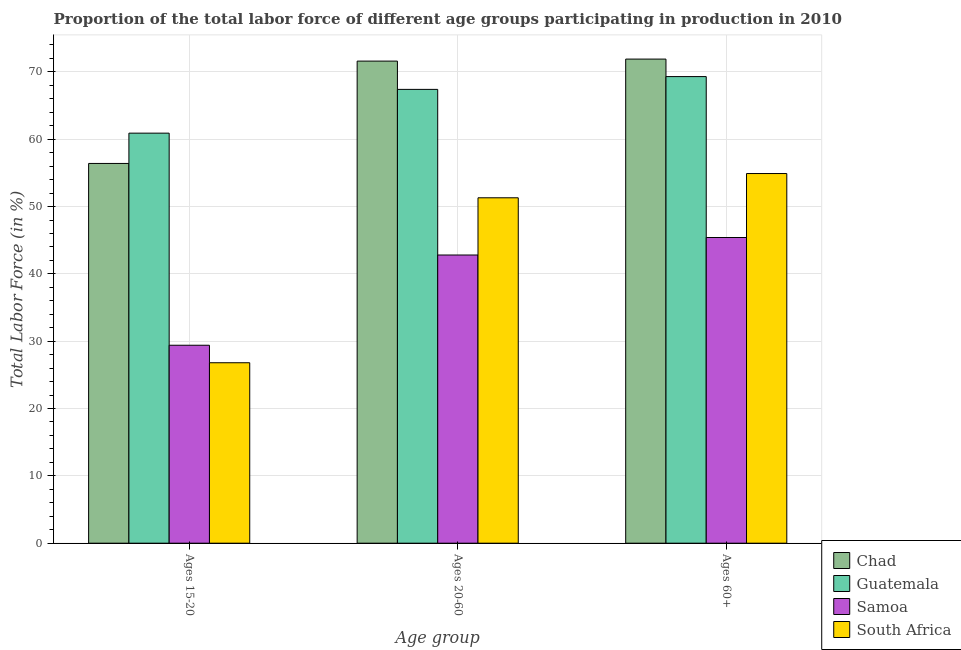How many different coloured bars are there?
Keep it short and to the point. 4. Are the number of bars on each tick of the X-axis equal?
Make the answer very short. Yes. How many bars are there on the 2nd tick from the left?
Offer a very short reply. 4. How many bars are there on the 3rd tick from the right?
Give a very brief answer. 4. What is the label of the 1st group of bars from the left?
Your answer should be compact. Ages 15-20. What is the percentage of labor force within the age group 20-60 in South Africa?
Provide a short and direct response. 51.3. Across all countries, what is the maximum percentage of labor force within the age group 20-60?
Offer a very short reply. 71.6. Across all countries, what is the minimum percentage of labor force within the age group 15-20?
Your answer should be compact. 26.8. In which country was the percentage of labor force within the age group 20-60 maximum?
Offer a terse response. Chad. In which country was the percentage of labor force within the age group 20-60 minimum?
Your answer should be compact. Samoa. What is the total percentage of labor force within the age group 15-20 in the graph?
Your answer should be very brief. 173.5. What is the difference between the percentage of labor force within the age group 20-60 in South Africa and that in Samoa?
Keep it short and to the point. 8.5. What is the difference between the percentage of labor force within the age group 20-60 in Samoa and the percentage of labor force within the age group 15-20 in Chad?
Offer a very short reply. -13.6. What is the average percentage of labor force within the age group 15-20 per country?
Give a very brief answer. 43.38. What is the difference between the percentage of labor force within the age group 15-20 and percentage of labor force above age 60 in South Africa?
Your answer should be very brief. -28.1. In how many countries, is the percentage of labor force within the age group 20-60 greater than 62 %?
Make the answer very short. 2. What is the ratio of the percentage of labor force above age 60 in Samoa to that in South Africa?
Your response must be concise. 0.83. Is the difference between the percentage of labor force within the age group 15-20 in South Africa and Samoa greater than the difference between the percentage of labor force above age 60 in South Africa and Samoa?
Keep it short and to the point. No. What is the difference between the highest and the second highest percentage of labor force above age 60?
Give a very brief answer. 2.6. What is the difference between the highest and the lowest percentage of labor force within the age group 20-60?
Keep it short and to the point. 28.8. What does the 2nd bar from the left in Ages 20-60 represents?
Provide a short and direct response. Guatemala. What does the 3rd bar from the right in Ages 60+ represents?
Provide a short and direct response. Guatemala. How many countries are there in the graph?
Ensure brevity in your answer.  4. Are the values on the major ticks of Y-axis written in scientific E-notation?
Your answer should be very brief. No. Does the graph contain any zero values?
Provide a short and direct response. No. How are the legend labels stacked?
Provide a succinct answer. Vertical. What is the title of the graph?
Your answer should be compact. Proportion of the total labor force of different age groups participating in production in 2010. What is the label or title of the X-axis?
Keep it short and to the point. Age group. What is the Total Labor Force (in %) in Chad in Ages 15-20?
Your answer should be compact. 56.4. What is the Total Labor Force (in %) in Guatemala in Ages 15-20?
Ensure brevity in your answer.  60.9. What is the Total Labor Force (in %) in Samoa in Ages 15-20?
Give a very brief answer. 29.4. What is the Total Labor Force (in %) of South Africa in Ages 15-20?
Your answer should be compact. 26.8. What is the Total Labor Force (in %) in Chad in Ages 20-60?
Offer a very short reply. 71.6. What is the Total Labor Force (in %) of Guatemala in Ages 20-60?
Keep it short and to the point. 67.4. What is the Total Labor Force (in %) of Samoa in Ages 20-60?
Your response must be concise. 42.8. What is the Total Labor Force (in %) of South Africa in Ages 20-60?
Your answer should be very brief. 51.3. What is the Total Labor Force (in %) of Chad in Ages 60+?
Make the answer very short. 71.9. What is the Total Labor Force (in %) of Guatemala in Ages 60+?
Offer a terse response. 69.3. What is the Total Labor Force (in %) of Samoa in Ages 60+?
Provide a short and direct response. 45.4. What is the Total Labor Force (in %) in South Africa in Ages 60+?
Ensure brevity in your answer.  54.9. Across all Age group, what is the maximum Total Labor Force (in %) of Chad?
Offer a very short reply. 71.9. Across all Age group, what is the maximum Total Labor Force (in %) in Guatemala?
Provide a succinct answer. 69.3. Across all Age group, what is the maximum Total Labor Force (in %) of Samoa?
Provide a succinct answer. 45.4. Across all Age group, what is the maximum Total Labor Force (in %) in South Africa?
Offer a very short reply. 54.9. Across all Age group, what is the minimum Total Labor Force (in %) of Chad?
Your answer should be very brief. 56.4. Across all Age group, what is the minimum Total Labor Force (in %) of Guatemala?
Provide a short and direct response. 60.9. Across all Age group, what is the minimum Total Labor Force (in %) of Samoa?
Make the answer very short. 29.4. Across all Age group, what is the minimum Total Labor Force (in %) in South Africa?
Your response must be concise. 26.8. What is the total Total Labor Force (in %) of Chad in the graph?
Your answer should be compact. 199.9. What is the total Total Labor Force (in %) in Guatemala in the graph?
Offer a terse response. 197.6. What is the total Total Labor Force (in %) in Samoa in the graph?
Provide a succinct answer. 117.6. What is the total Total Labor Force (in %) of South Africa in the graph?
Provide a short and direct response. 133. What is the difference between the Total Labor Force (in %) in Chad in Ages 15-20 and that in Ages 20-60?
Your response must be concise. -15.2. What is the difference between the Total Labor Force (in %) of South Africa in Ages 15-20 and that in Ages 20-60?
Provide a short and direct response. -24.5. What is the difference between the Total Labor Force (in %) in Chad in Ages 15-20 and that in Ages 60+?
Keep it short and to the point. -15.5. What is the difference between the Total Labor Force (in %) in South Africa in Ages 15-20 and that in Ages 60+?
Make the answer very short. -28.1. What is the difference between the Total Labor Force (in %) in South Africa in Ages 20-60 and that in Ages 60+?
Make the answer very short. -3.6. What is the difference between the Total Labor Force (in %) in Chad in Ages 15-20 and the Total Labor Force (in %) in Samoa in Ages 20-60?
Provide a short and direct response. 13.6. What is the difference between the Total Labor Force (in %) of Chad in Ages 15-20 and the Total Labor Force (in %) of South Africa in Ages 20-60?
Provide a short and direct response. 5.1. What is the difference between the Total Labor Force (in %) in Samoa in Ages 15-20 and the Total Labor Force (in %) in South Africa in Ages 20-60?
Offer a terse response. -21.9. What is the difference between the Total Labor Force (in %) in Chad in Ages 15-20 and the Total Labor Force (in %) in Guatemala in Ages 60+?
Your response must be concise. -12.9. What is the difference between the Total Labor Force (in %) in Chad in Ages 15-20 and the Total Labor Force (in %) in South Africa in Ages 60+?
Ensure brevity in your answer.  1.5. What is the difference between the Total Labor Force (in %) of Guatemala in Ages 15-20 and the Total Labor Force (in %) of Samoa in Ages 60+?
Your response must be concise. 15.5. What is the difference between the Total Labor Force (in %) in Guatemala in Ages 15-20 and the Total Labor Force (in %) in South Africa in Ages 60+?
Your answer should be very brief. 6. What is the difference between the Total Labor Force (in %) of Samoa in Ages 15-20 and the Total Labor Force (in %) of South Africa in Ages 60+?
Offer a terse response. -25.5. What is the difference between the Total Labor Force (in %) in Chad in Ages 20-60 and the Total Labor Force (in %) in Samoa in Ages 60+?
Keep it short and to the point. 26.2. What is the average Total Labor Force (in %) of Chad per Age group?
Make the answer very short. 66.63. What is the average Total Labor Force (in %) of Guatemala per Age group?
Offer a terse response. 65.87. What is the average Total Labor Force (in %) of Samoa per Age group?
Your response must be concise. 39.2. What is the average Total Labor Force (in %) of South Africa per Age group?
Ensure brevity in your answer.  44.33. What is the difference between the Total Labor Force (in %) of Chad and Total Labor Force (in %) of Guatemala in Ages 15-20?
Ensure brevity in your answer.  -4.5. What is the difference between the Total Labor Force (in %) of Chad and Total Labor Force (in %) of Samoa in Ages 15-20?
Ensure brevity in your answer.  27. What is the difference between the Total Labor Force (in %) in Chad and Total Labor Force (in %) in South Africa in Ages 15-20?
Keep it short and to the point. 29.6. What is the difference between the Total Labor Force (in %) of Guatemala and Total Labor Force (in %) of Samoa in Ages 15-20?
Offer a very short reply. 31.5. What is the difference between the Total Labor Force (in %) of Guatemala and Total Labor Force (in %) of South Africa in Ages 15-20?
Ensure brevity in your answer.  34.1. What is the difference between the Total Labor Force (in %) in Chad and Total Labor Force (in %) in Samoa in Ages 20-60?
Provide a short and direct response. 28.8. What is the difference between the Total Labor Force (in %) of Chad and Total Labor Force (in %) of South Africa in Ages 20-60?
Provide a short and direct response. 20.3. What is the difference between the Total Labor Force (in %) in Guatemala and Total Labor Force (in %) in Samoa in Ages 20-60?
Provide a short and direct response. 24.6. What is the difference between the Total Labor Force (in %) in Samoa and Total Labor Force (in %) in South Africa in Ages 20-60?
Offer a very short reply. -8.5. What is the difference between the Total Labor Force (in %) in Chad and Total Labor Force (in %) in Samoa in Ages 60+?
Your answer should be compact. 26.5. What is the difference between the Total Labor Force (in %) of Chad and Total Labor Force (in %) of South Africa in Ages 60+?
Ensure brevity in your answer.  17. What is the difference between the Total Labor Force (in %) of Guatemala and Total Labor Force (in %) of Samoa in Ages 60+?
Keep it short and to the point. 23.9. What is the difference between the Total Labor Force (in %) of Guatemala and Total Labor Force (in %) of South Africa in Ages 60+?
Offer a terse response. 14.4. What is the difference between the Total Labor Force (in %) of Samoa and Total Labor Force (in %) of South Africa in Ages 60+?
Your response must be concise. -9.5. What is the ratio of the Total Labor Force (in %) in Chad in Ages 15-20 to that in Ages 20-60?
Your answer should be compact. 0.79. What is the ratio of the Total Labor Force (in %) of Guatemala in Ages 15-20 to that in Ages 20-60?
Give a very brief answer. 0.9. What is the ratio of the Total Labor Force (in %) in Samoa in Ages 15-20 to that in Ages 20-60?
Your answer should be compact. 0.69. What is the ratio of the Total Labor Force (in %) in South Africa in Ages 15-20 to that in Ages 20-60?
Provide a short and direct response. 0.52. What is the ratio of the Total Labor Force (in %) of Chad in Ages 15-20 to that in Ages 60+?
Offer a very short reply. 0.78. What is the ratio of the Total Labor Force (in %) of Guatemala in Ages 15-20 to that in Ages 60+?
Provide a succinct answer. 0.88. What is the ratio of the Total Labor Force (in %) of Samoa in Ages 15-20 to that in Ages 60+?
Offer a terse response. 0.65. What is the ratio of the Total Labor Force (in %) in South Africa in Ages 15-20 to that in Ages 60+?
Give a very brief answer. 0.49. What is the ratio of the Total Labor Force (in %) of Chad in Ages 20-60 to that in Ages 60+?
Your answer should be compact. 1. What is the ratio of the Total Labor Force (in %) of Guatemala in Ages 20-60 to that in Ages 60+?
Your response must be concise. 0.97. What is the ratio of the Total Labor Force (in %) of Samoa in Ages 20-60 to that in Ages 60+?
Offer a terse response. 0.94. What is the ratio of the Total Labor Force (in %) in South Africa in Ages 20-60 to that in Ages 60+?
Offer a terse response. 0.93. What is the difference between the highest and the second highest Total Labor Force (in %) in Chad?
Your response must be concise. 0.3. What is the difference between the highest and the second highest Total Labor Force (in %) in Guatemala?
Provide a short and direct response. 1.9. What is the difference between the highest and the second highest Total Labor Force (in %) in Samoa?
Your response must be concise. 2.6. What is the difference between the highest and the second highest Total Labor Force (in %) of South Africa?
Your response must be concise. 3.6. What is the difference between the highest and the lowest Total Labor Force (in %) of Chad?
Make the answer very short. 15.5. What is the difference between the highest and the lowest Total Labor Force (in %) in Guatemala?
Provide a short and direct response. 8.4. What is the difference between the highest and the lowest Total Labor Force (in %) in Samoa?
Provide a short and direct response. 16. What is the difference between the highest and the lowest Total Labor Force (in %) of South Africa?
Keep it short and to the point. 28.1. 